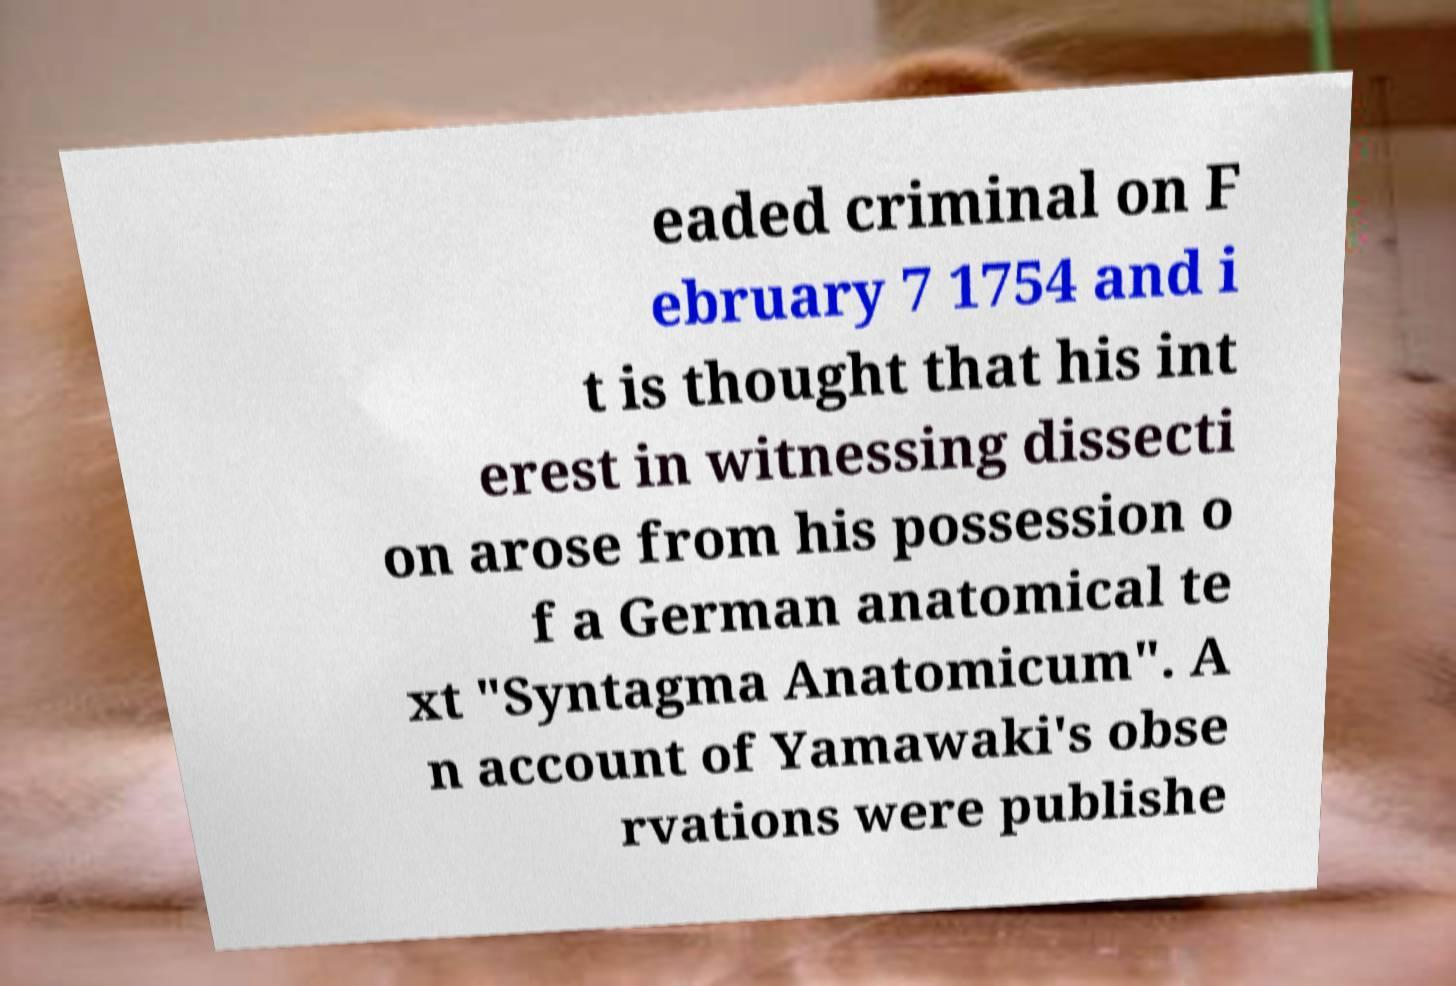Please identify and transcribe the text found in this image. eaded criminal on F ebruary 7 1754 and i t is thought that his int erest in witnessing dissecti on arose from his possession o f a German anatomical te xt "Syntagma Anatomicum". A n account of Yamawaki's obse rvations were publishe 